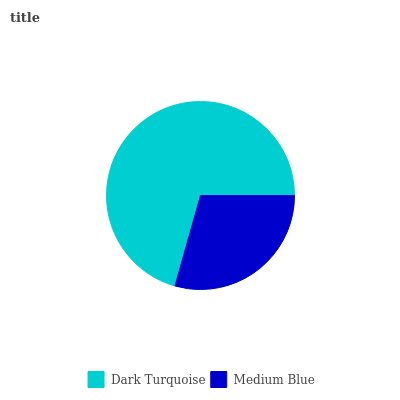Is Medium Blue the minimum?
Answer yes or no. Yes. Is Dark Turquoise the maximum?
Answer yes or no. Yes. Is Medium Blue the maximum?
Answer yes or no. No. Is Dark Turquoise greater than Medium Blue?
Answer yes or no. Yes. Is Medium Blue less than Dark Turquoise?
Answer yes or no. Yes. Is Medium Blue greater than Dark Turquoise?
Answer yes or no. No. Is Dark Turquoise less than Medium Blue?
Answer yes or no. No. Is Dark Turquoise the high median?
Answer yes or no. Yes. Is Medium Blue the low median?
Answer yes or no. Yes. Is Medium Blue the high median?
Answer yes or no. No. Is Dark Turquoise the low median?
Answer yes or no. No. 